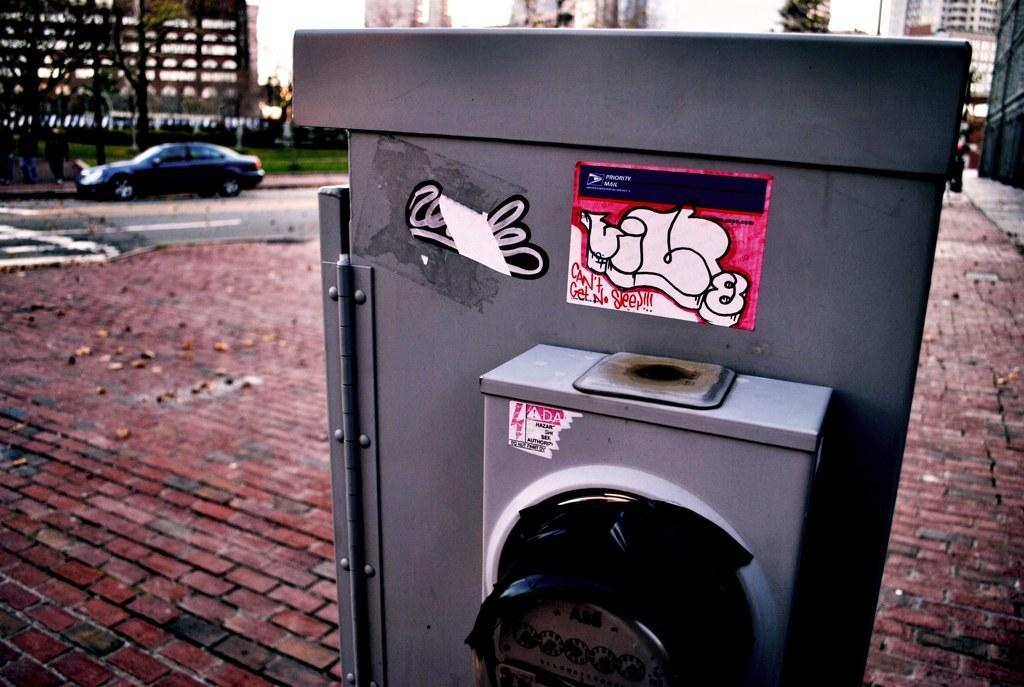<image>
Offer a succinct explanation of the picture presented. COntainer outdoors with a graffiti on it which says Can't Get No Sleep. 